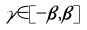<formula> <loc_0><loc_0><loc_500><loc_500>\gamma \in [ - \beta , \beta ]</formula> 